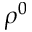Convert formula to latex. <formula><loc_0><loc_0><loc_500><loc_500>\rho ^ { 0 }</formula> 